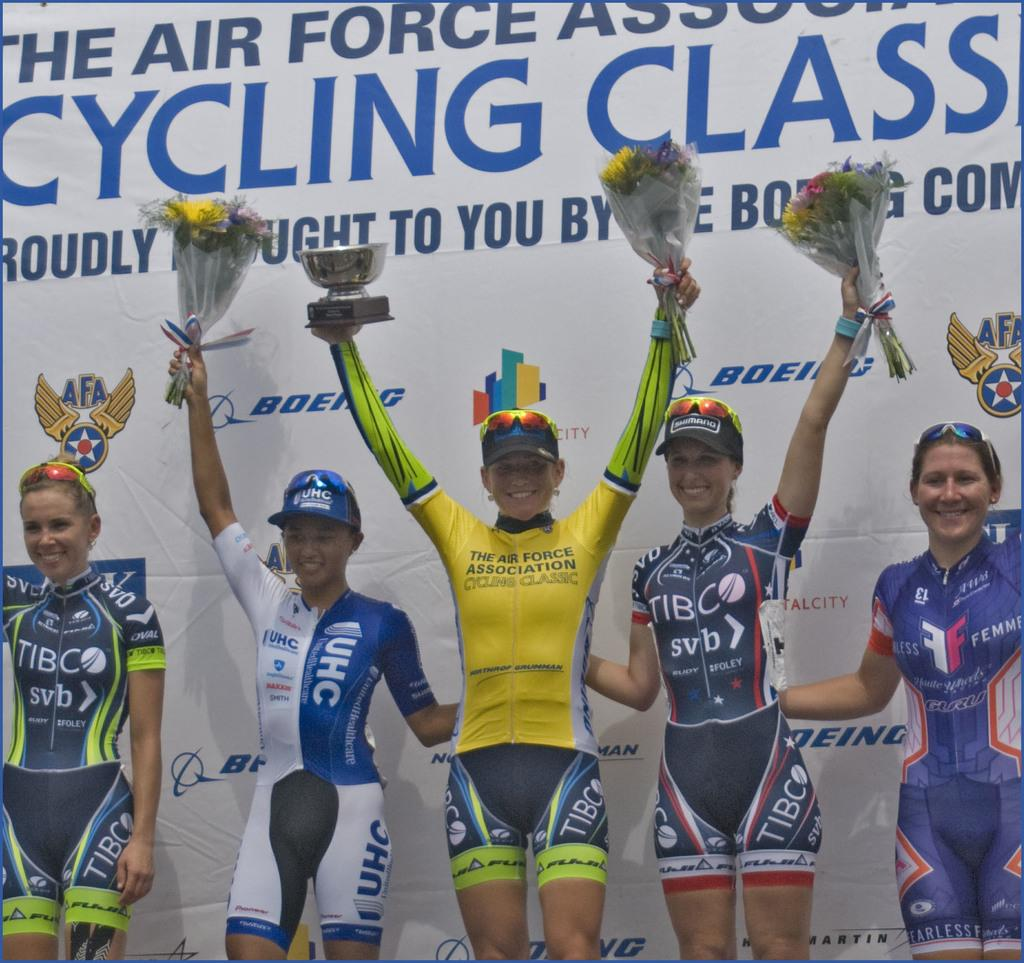<image>
Offer a succinct explanation of the picture presented. Women stand holding flowers in front of a wall that says cycling class. 